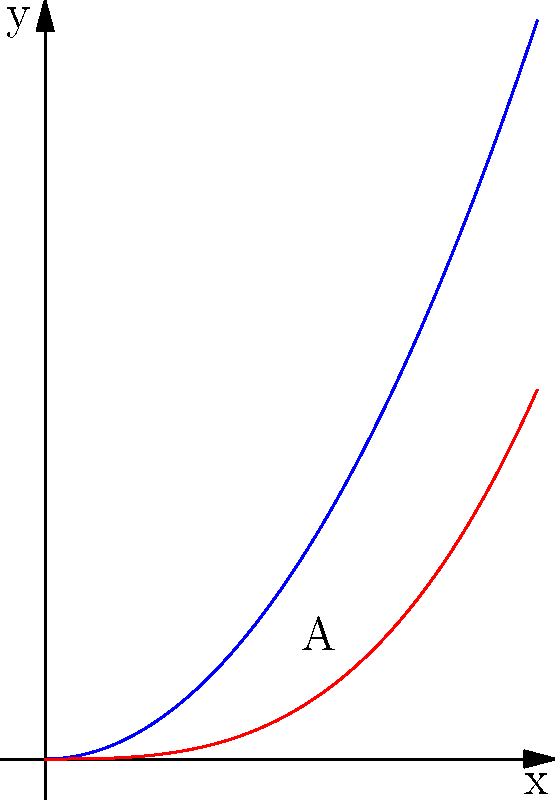Consider the region A bounded by the curves $y = x^2$ and $y = \frac{x^3}{3}$ from $x = 0$ to their point of intersection. Find the area of region A using integration. To find the area between two curves, we need to follow these steps:

1) First, find the point of intersection of the two curves:
   $x^2 = \frac{x^3}{3}$
   $3x^2 = x^3$
   $x(3x - x^2) = 0$
   $x = 0$ or $x = 3$

   The relevant point of intersection is $(1,1)$.

2) Set up the integral. The area is given by:
   $A = \int_0^1 (x^2 - \frac{x^3}{3}) dx$

3) Evaluate the integral:
   $A = \int_0^1 (x^2 - \frac{x^3}{3}) dx$
   $= [\frac{x^3}{3} - \frac{x^4}{12}]_0^1$
   $= (\frac{1}{3} - \frac{1}{12}) - (0 - 0)$
   $= \frac{1}{3} - \frac{1}{12}$
   $= \frac{4}{12} - \frac{1}{12}$
   $= \frac{3}{12}$
   $= \frac{1}{4}$

Therefore, the area of region A is $\frac{1}{4}$ square units.
Answer: $\frac{1}{4}$ square units 